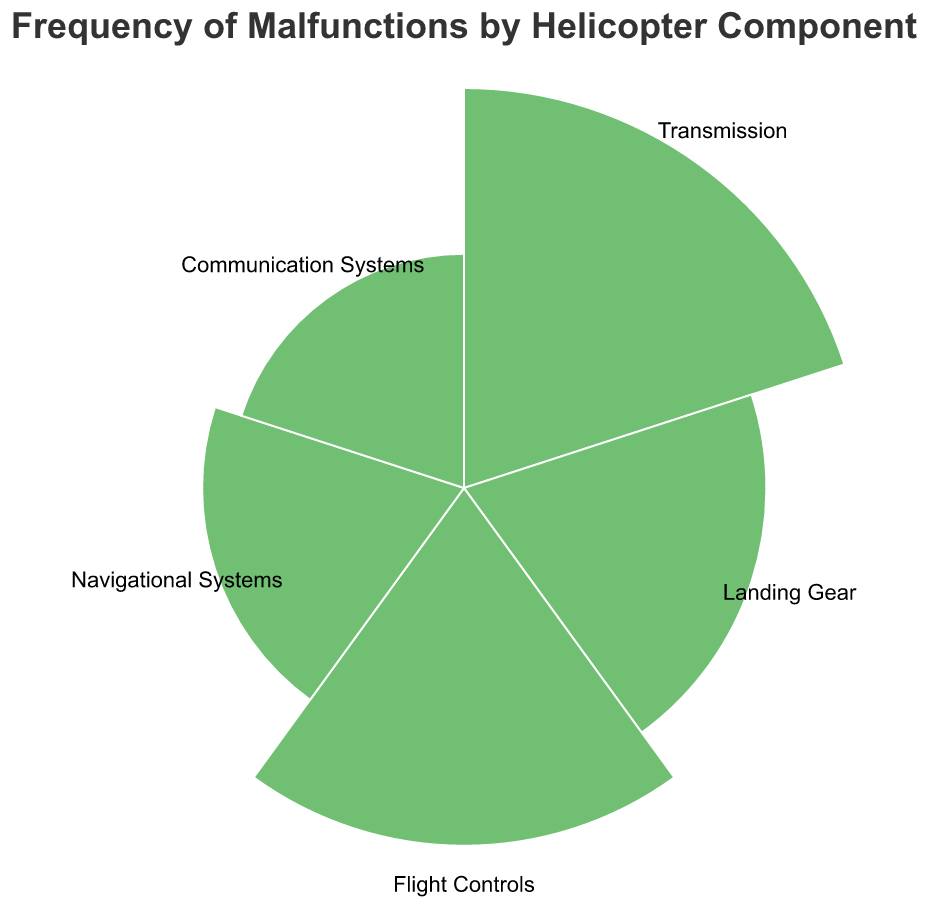What is the title of the polar chart? The title is displayed at the top of the chart and describes the focus of the data being visualized.
Answer: Frequency of Malfunctions by Helicopter Component Which helicopter component has the highest frequency of malfunctions? By examining the polar chart, look for the arc with the largest radius, which indicates the highest frequency. In this case, it's the sector corresponding to the Transmission component.
Answer: Transmission What is the combined frequency of malfunctions for Flight Controls and Landing Gear? Identify the frequencies for both components from the chart (Flight Controls is 28 and Landing Gear is 20) and sum them up: 28 + 20 = 48.
Answer: 48 How does the frequency of malfunctions for Navigational Systems compare to Communication Systems? Compare the radii of the sectors for Navigational Systems and Communication Systems. Navigational Systems have a higher frequency (15) than Communication Systems (12).
Answer: Navigational Systems is higher Which component has the second highest frequency of malfunctions? After identifying the highest value (Transmission with 35), determine the next highest value from the remaining components. This is Flight Controls with a frequency of 28.
Answer: Flight Controls What is the average frequency of malfunctions across all components? Sum the frequencies (35 + 20 + 28 + 15 + 12 = 110) and divide by the number of components (5). 110 / 5 = 22.
Answer: 22 What is the difference in frequency of malfunctions between Transmission and Landing Gear? Identify the frequencies (Transmission is 35 and Landing Gear is 20) and find the difference: 35 - 20 = 15.
Answer: 15 Are there any components with exactly the same frequency of malfunctions? Examine the frequencies of all components. Each component has a unique frequency.
Answer: No What is the total frequency of malfunctions for all components combined? Sum the frequencies of all the components: 35 (Transmission) + 20 (Landing Gear) + 28 (Flight Controls) + 15 (Navigational Systems) + 12 (Communication Systems) = 110.
Answer: 110 Which component has the smallest frequency of malfunctions? Find the component with the smallest sector radius, which corresponds to the Communications Systems with a frequency of 12.
Answer: Communication Systems 